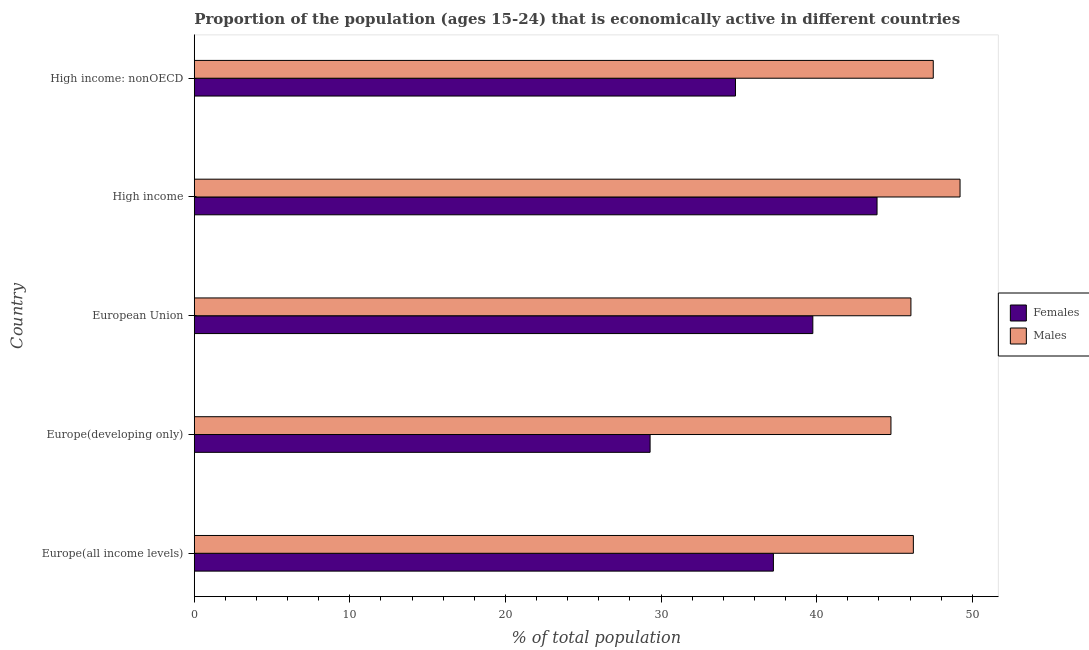How many groups of bars are there?
Provide a short and direct response. 5. Are the number of bars per tick equal to the number of legend labels?
Give a very brief answer. Yes. Are the number of bars on each tick of the Y-axis equal?
Give a very brief answer. Yes. How many bars are there on the 4th tick from the top?
Give a very brief answer. 2. How many bars are there on the 3rd tick from the bottom?
Provide a short and direct response. 2. What is the label of the 3rd group of bars from the top?
Make the answer very short. European Union. In how many cases, is the number of bars for a given country not equal to the number of legend labels?
Ensure brevity in your answer.  0. What is the percentage of economically active male population in Europe(developing only)?
Offer a terse response. 44.77. Across all countries, what is the maximum percentage of economically active male population?
Your response must be concise. 49.21. Across all countries, what is the minimum percentage of economically active female population?
Keep it short and to the point. 29.29. In which country was the percentage of economically active male population maximum?
Your answer should be very brief. High income. In which country was the percentage of economically active female population minimum?
Provide a short and direct response. Europe(developing only). What is the total percentage of economically active male population in the graph?
Offer a very short reply. 233.75. What is the difference between the percentage of economically active male population in Europe(developing only) and that in High income: nonOECD?
Ensure brevity in your answer.  -2.72. What is the difference between the percentage of economically active male population in Europe(all income levels) and the percentage of economically active female population in European Union?
Provide a short and direct response. 6.46. What is the average percentage of economically active male population per country?
Offer a terse response. 46.75. What is the difference between the percentage of economically active male population and percentage of economically active female population in Europe(developing only)?
Ensure brevity in your answer.  15.48. In how many countries, is the percentage of economically active male population greater than 44 %?
Offer a terse response. 5. Is the percentage of economically active male population in European Union less than that in High income: nonOECD?
Your response must be concise. Yes. Is the difference between the percentage of economically active female population in Europe(developing only) and European Union greater than the difference between the percentage of economically active male population in Europe(developing only) and European Union?
Make the answer very short. No. What is the difference between the highest and the second highest percentage of economically active male population?
Provide a succinct answer. 1.72. What is the difference between the highest and the lowest percentage of economically active female population?
Keep it short and to the point. 14.58. In how many countries, is the percentage of economically active female population greater than the average percentage of economically active female population taken over all countries?
Your answer should be compact. 3. Is the sum of the percentage of economically active male population in Europe(all income levels) and High income greater than the maximum percentage of economically active female population across all countries?
Give a very brief answer. Yes. What does the 2nd bar from the top in Europe(developing only) represents?
Your answer should be compact. Females. What does the 1st bar from the bottom in High income represents?
Your response must be concise. Females. How many bars are there?
Offer a terse response. 10. What is the difference between two consecutive major ticks on the X-axis?
Your response must be concise. 10. How many legend labels are there?
Ensure brevity in your answer.  2. What is the title of the graph?
Keep it short and to the point. Proportion of the population (ages 15-24) that is economically active in different countries. What is the label or title of the X-axis?
Your response must be concise. % of total population. What is the % of total population in Females in Europe(all income levels)?
Ensure brevity in your answer.  37.22. What is the % of total population in Males in Europe(all income levels)?
Make the answer very short. 46.21. What is the % of total population in Females in Europe(developing only)?
Make the answer very short. 29.29. What is the % of total population of Males in Europe(developing only)?
Make the answer very short. 44.77. What is the % of total population of Females in European Union?
Provide a short and direct response. 39.75. What is the % of total population of Males in European Union?
Provide a short and direct response. 46.06. What is the % of total population in Females in High income?
Your answer should be compact. 43.88. What is the % of total population in Males in High income?
Make the answer very short. 49.21. What is the % of total population of Females in High income: nonOECD?
Your answer should be very brief. 34.78. What is the % of total population of Males in High income: nonOECD?
Your answer should be compact. 47.49. Across all countries, what is the maximum % of total population of Females?
Your answer should be very brief. 43.88. Across all countries, what is the maximum % of total population in Males?
Give a very brief answer. 49.21. Across all countries, what is the minimum % of total population of Females?
Ensure brevity in your answer.  29.29. Across all countries, what is the minimum % of total population of Males?
Your answer should be very brief. 44.77. What is the total % of total population in Females in the graph?
Make the answer very short. 184.93. What is the total % of total population in Males in the graph?
Your answer should be very brief. 233.75. What is the difference between the % of total population in Females in Europe(all income levels) and that in Europe(developing only)?
Keep it short and to the point. 7.92. What is the difference between the % of total population in Males in Europe(all income levels) and that in Europe(developing only)?
Give a very brief answer. 1.44. What is the difference between the % of total population of Females in Europe(all income levels) and that in European Union?
Your response must be concise. -2.53. What is the difference between the % of total population of Males in Europe(all income levels) and that in European Union?
Offer a very short reply. 0.16. What is the difference between the % of total population in Females in Europe(all income levels) and that in High income?
Give a very brief answer. -6.66. What is the difference between the % of total population of Males in Europe(all income levels) and that in High income?
Your answer should be compact. -3. What is the difference between the % of total population of Females in Europe(all income levels) and that in High income: nonOECD?
Your answer should be very brief. 2.44. What is the difference between the % of total population in Males in Europe(all income levels) and that in High income: nonOECD?
Your answer should be very brief. -1.28. What is the difference between the % of total population in Females in Europe(developing only) and that in European Union?
Provide a short and direct response. -10.46. What is the difference between the % of total population of Males in Europe(developing only) and that in European Union?
Provide a short and direct response. -1.28. What is the difference between the % of total population in Females in Europe(developing only) and that in High income?
Offer a terse response. -14.58. What is the difference between the % of total population in Males in Europe(developing only) and that in High income?
Provide a short and direct response. -4.44. What is the difference between the % of total population in Females in Europe(developing only) and that in High income: nonOECD?
Offer a very short reply. -5.49. What is the difference between the % of total population in Males in Europe(developing only) and that in High income: nonOECD?
Ensure brevity in your answer.  -2.72. What is the difference between the % of total population in Females in European Union and that in High income?
Make the answer very short. -4.13. What is the difference between the % of total population of Males in European Union and that in High income?
Ensure brevity in your answer.  -3.16. What is the difference between the % of total population of Females in European Union and that in High income: nonOECD?
Give a very brief answer. 4.97. What is the difference between the % of total population of Males in European Union and that in High income: nonOECD?
Provide a succinct answer. -1.44. What is the difference between the % of total population in Females in High income and that in High income: nonOECD?
Offer a very short reply. 9.1. What is the difference between the % of total population in Males in High income and that in High income: nonOECD?
Offer a very short reply. 1.72. What is the difference between the % of total population of Females in Europe(all income levels) and the % of total population of Males in Europe(developing only)?
Make the answer very short. -7.56. What is the difference between the % of total population in Females in Europe(all income levels) and the % of total population in Males in European Union?
Provide a succinct answer. -8.84. What is the difference between the % of total population in Females in Europe(all income levels) and the % of total population in Males in High income?
Ensure brevity in your answer.  -11.99. What is the difference between the % of total population in Females in Europe(all income levels) and the % of total population in Males in High income: nonOECD?
Give a very brief answer. -10.27. What is the difference between the % of total population of Females in Europe(developing only) and the % of total population of Males in European Union?
Provide a short and direct response. -16.76. What is the difference between the % of total population in Females in Europe(developing only) and the % of total population in Males in High income?
Provide a short and direct response. -19.92. What is the difference between the % of total population of Females in Europe(developing only) and the % of total population of Males in High income: nonOECD?
Provide a short and direct response. -18.2. What is the difference between the % of total population of Females in European Union and the % of total population of Males in High income?
Make the answer very short. -9.46. What is the difference between the % of total population of Females in European Union and the % of total population of Males in High income: nonOECD?
Give a very brief answer. -7.74. What is the difference between the % of total population of Females in High income and the % of total population of Males in High income: nonOECD?
Keep it short and to the point. -3.61. What is the average % of total population of Females per country?
Your response must be concise. 36.99. What is the average % of total population in Males per country?
Offer a terse response. 46.75. What is the difference between the % of total population in Females and % of total population in Males in Europe(all income levels)?
Your response must be concise. -8.99. What is the difference between the % of total population of Females and % of total population of Males in Europe(developing only)?
Your answer should be very brief. -15.48. What is the difference between the % of total population of Females and % of total population of Males in European Union?
Offer a very short reply. -6.3. What is the difference between the % of total population of Females and % of total population of Males in High income?
Offer a terse response. -5.33. What is the difference between the % of total population in Females and % of total population in Males in High income: nonOECD?
Keep it short and to the point. -12.71. What is the ratio of the % of total population of Females in Europe(all income levels) to that in Europe(developing only)?
Offer a very short reply. 1.27. What is the ratio of the % of total population in Males in Europe(all income levels) to that in Europe(developing only)?
Provide a short and direct response. 1.03. What is the ratio of the % of total population of Females in Europe(all income levels) to that in European Union?
Make the answer very short. 0.94. What is the ratio of the % of total population of Males in Europe(all income levels) to that in European Union?
Keep it short and to the point. 1. What is the ratio of the % of total population of Females in Europe(all income levels) to that in High income?
Provide a succinct answer. 0.85. What is the ratio of the % of total population in Males in Europe(all income levels) to that in High income?
Ensure brevity in your answer.  0.94. What is the ratio of the % of total population of Females in Europe(all income levels) to that in High income: nonOECD?
Keep it short and to the point. 1.07. What is the ratio of the % of total population in Males in Europe(all income levels) to that in High income: nonOECD?
Your response must be concise. 0.97. What is the ratio of the % of total population of Females in Europe(developing only) to that in European Union?
Provide a succinct answer. 0.74. What is the ratio of the % of total population of Males in Europe(developing only) to that in European Union?
Offer a terse response. 0.97. What is the ratio of the % of total population of Females in Europe(developing only) to that in High income?
Your response must be concise. 0.67. What is the ratio of the % of total population in Males in Europe(developing only) to that in High income?
Provide a short and direct response. 0.91. What is the ratio of the % of total population of Females in Europe(developing only) to that in High income: nonOECD?
Ensure brevity in your answer.  0.84. What is the ratio of the % of total population of Males in Europe(developing only) to that in High income: nonOECD?
Your answer should be very brief. 0.94. What is the ratio of the % of total population of Females in European Union to that in High income?
Offer a very short reply. 0.91. What is the ratio of the % of total population in Males in European Union to that in High income?
Keep it short and to the point. 0.94. What is the ratio of the % of total population in Males in European Union to that in High income: nonOECD?
Provide a short and direct response. 0.97. What is the ratio of the % of total population of Females in High income to that in High income: nonOECD?
Provide a succinct answer. 1.26. What is the ratio of the % of total population of Males in High income to that in High income: nonOECD?
Give a very brief answer. 1.04. What is the difference between the highest and the second highest % of total population of Females?
Keep it short and to the point. 4.13. What is the difference between the highest and the second highest % of total population of Males?
Keep it short and to the point. 1.72. What is the difference between the highest and the lowest % of total population of Females?
Ensure brevity in your answer.  14.58. What is the difference between the highest and the lowest % of total population of Males?
Offer a very short reply. 4.44. 